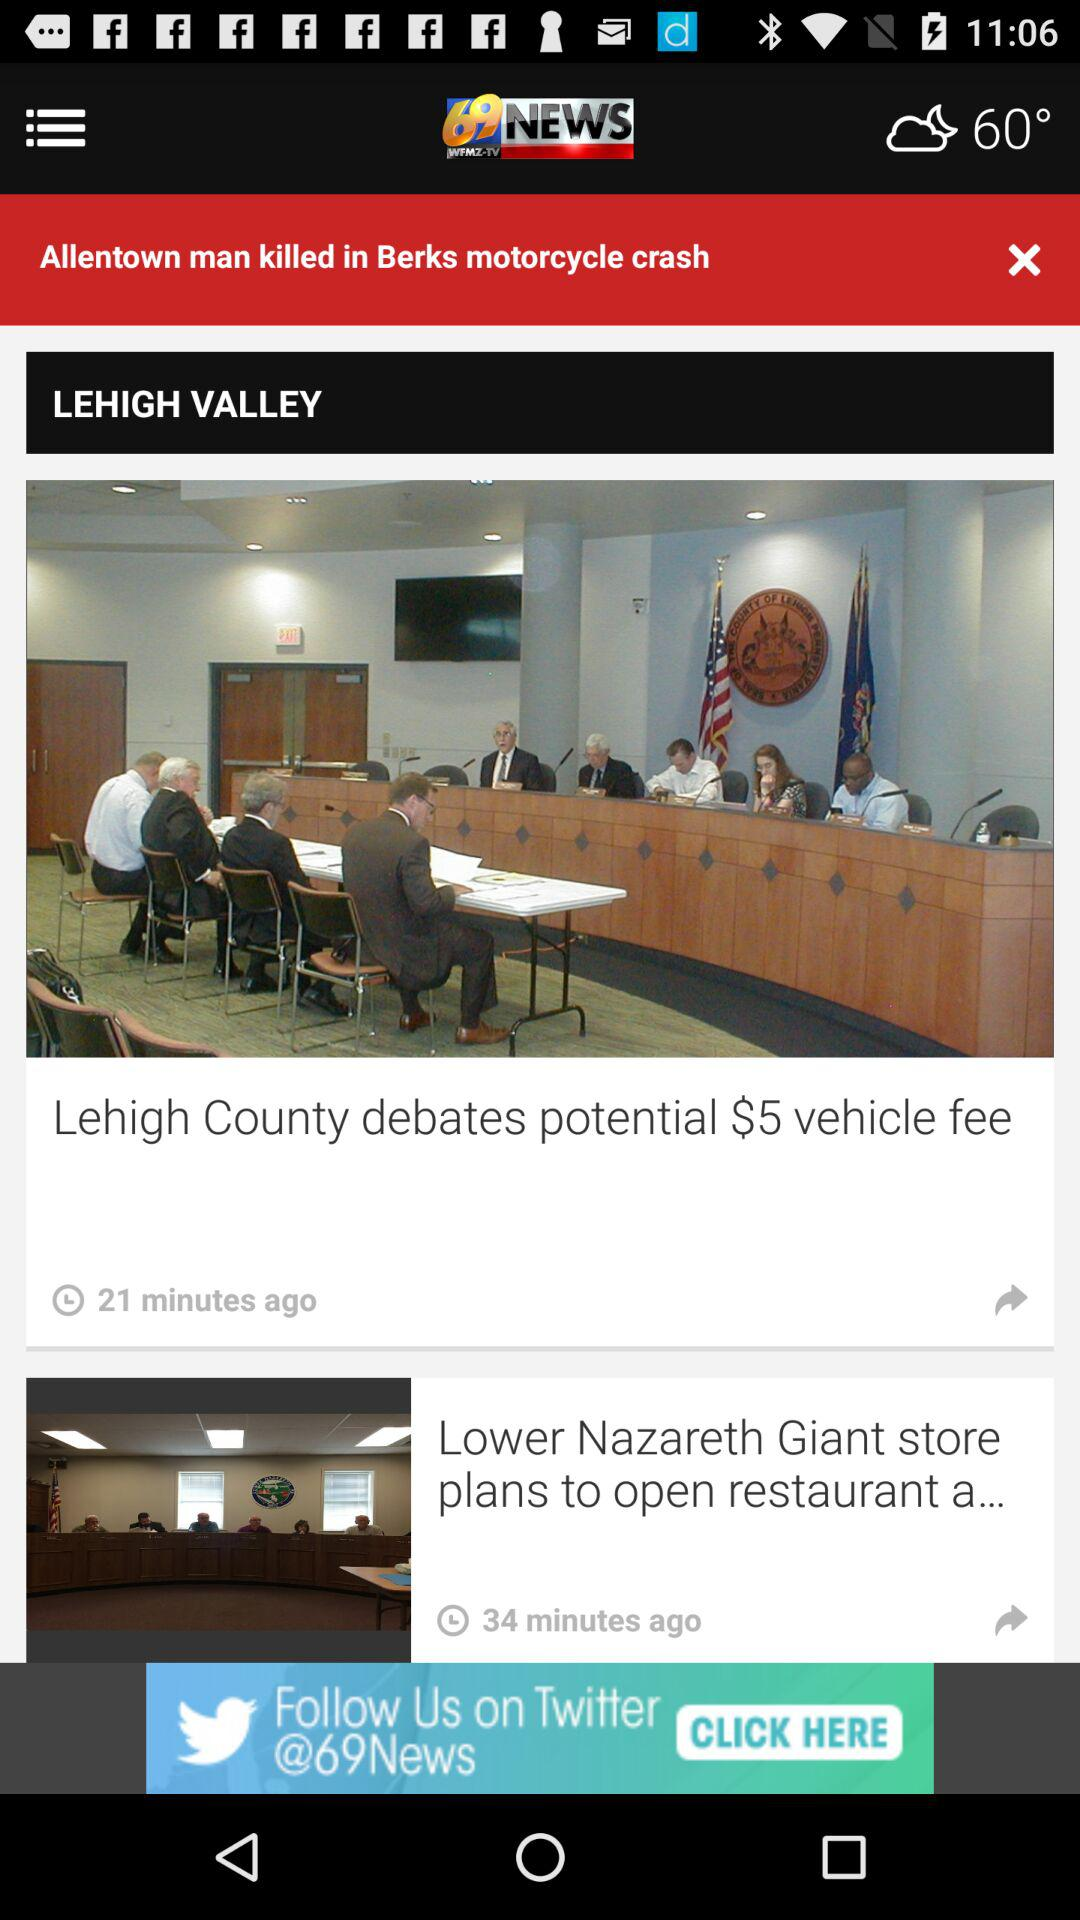How many more minutes ago was the article about the Lehigh County debates potential $5 vehicle fee published than the article about the Lower Nazareth Giant store plans to open restaurant?
Answer the question using a single word or phrase. 13 